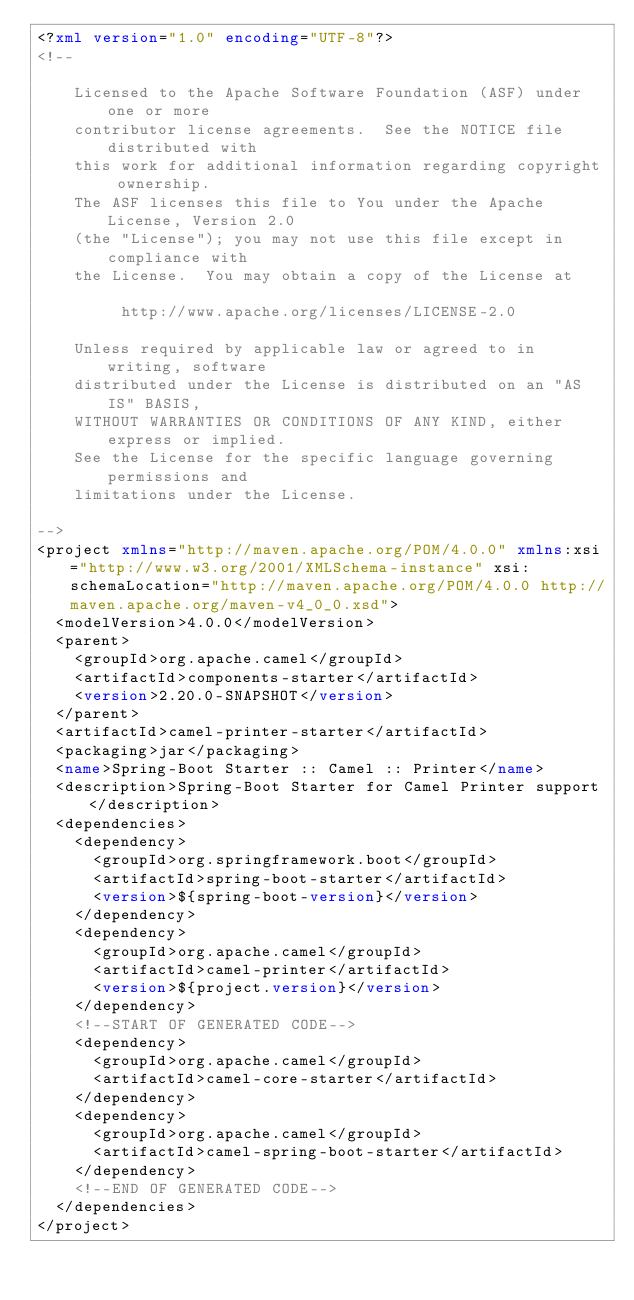<code> <loc_0><loc_0><loc_500><loc_500><_XML_><?xml version="1.0" encoding="UTF-8"?>
<!--

    Licensed to the Apache Software Foundation (ASF) under one or more
    contributor license agreements.  See the NOTICE file distributed with
    this work for additional information regarding copyright ownership.
    The ASF licenses this file to You under the Apache License, Version 2.0
    (the "License"); you may not use this file except in compliance with
    the License.  You may obtain a copy of the License at

         http://www.apache.org/licenses/LICENSE-2.0

    Unless required by applicable law or agreed to in writing, software
    distributed under the License is distributed on an "AS IS" BASIS,
    WITHOUT WARRANTIES OR CONDITIONS OF ANY KIND, either express or implied.
    See the License for the specific language governing permissions and
    limitations under the License.

-->
<project xmlns="http://maven.apache.org/POM/4.0.0" xmlns:xsi="http://www.w3.org/2001/XMLSchema-instance" xsi:schemaLocation="http://maven.apache.org/POM/4.0.0 http://maven.apache.org/maven-v4_0_0.xsd">
  <modelVersion>4.0.0</modelVersion>
  <parent>
    <groupId>org.apache.camel</groupId>
    <artifactId>components-starter</artifactId>
    <version>2.20.0-SNAPSHOT</version>
  </parent>
  <artifactId>camel-printer-starter</artifactId>
  <packaging>jar</packaging>
  <name>Spring-Boot Starter :: Camel :: Printer</name>
  <description>Spring-Boot Starter for Camel Printer support</description>
  <dependencies>
    <dependency>
      <groupId>org.springframework.boot</groupId>
      <artifactId>spring-boot-starter</artifactId>
      <version>${spring-boot-version}</version>
    </dependency>
    <dependency>
      <groupId>org.apache.camel</groupId>
      <artifactId>camel-printer</artifactId>
      <version>${project.version}</version>
    </dependency>
    <!--START OF GENERATED CODE-->
    <dependency>
      <groupId>org.apache.camel</groupId>
      <artifactId>camel-core-starter</artifactId>
    </dependency>
    <dependency>
      <groupId>org.apache.camel</groupId>
      <artifactId>camel-spring-boot-starter</artifactId>
    </dependency>
    <!--END OF GENERATED CODE-->
  </dependencies>
</project>
</code> 